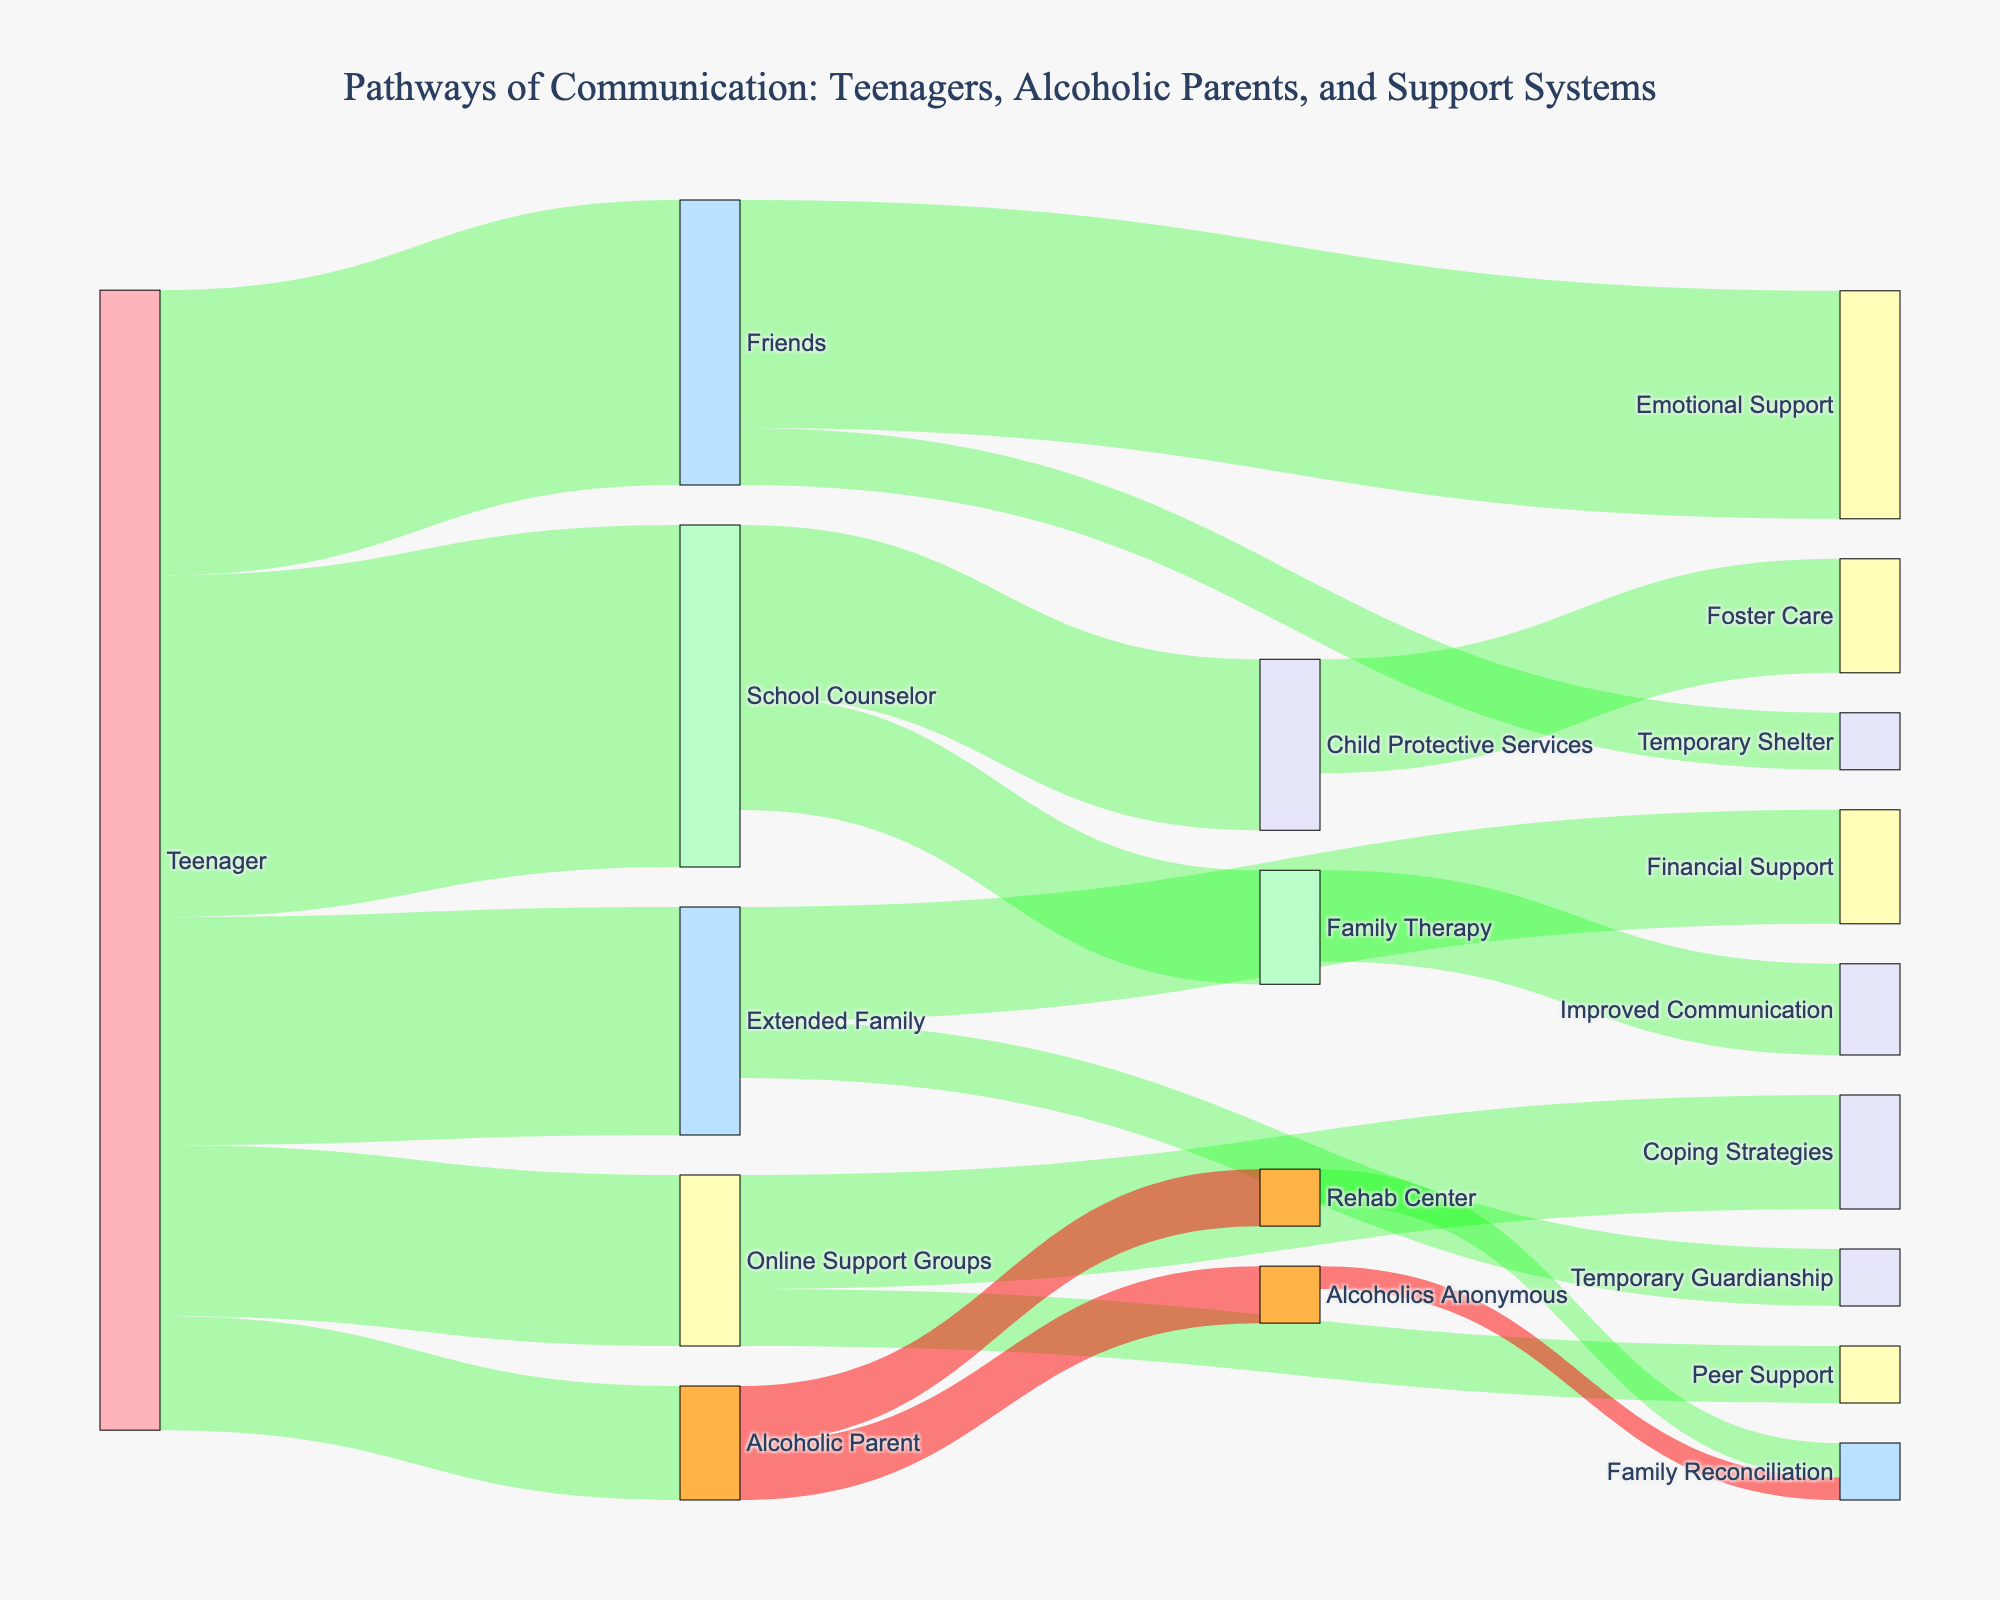what is the title of the Sankey diagram? The title is located at the top center of the diagram, providing a clear overall description of the visualization. It helps in understanding what the data is about immediately.
Answer: Pathways of Communication: Teenagers, Alcoholic Parents, and Support Systems which pathway has the largest value originating from the Teenager? To find the largest value originating from the Teenager, look at the thickness of the links extending from the Teenager and identify the one with the largest width. In this case, the largest value is visually evident by comparing the sizes of the different connections.
Answer: School Counselor how many different support sources are there for the teenager? To find this, count the individual nodes that have lines originating from the Teenager node. Each node connected directly to the Teenager represents a different support source.
Answer: 5 how many nodes are involved in total communication pathways? Count all the unique nodes (both sources and targets) in the diagram, as each node represents a different entity or process in the communication pathways.
Answer: 15 which pathway originating from the School Counselor has the least value? Look at the nodes connected to the School Counselor and compare the widths of the links to determine which one is the thinnest. The smallest value indicates the least pathway value.
Answer: Family Therapy compare the values of pathways from Friends. Which one offers more support, emotional or temporary shelter? Look at the two pathways originating from the Friends node and compare their widths. The pathway with the thicker width represents the higher value, hence more support. Emotional Support has a value of 20, and Temporary Shelter has a value of 5.
Answer: Emotional Support which node has pathways that lead directly to Family Reconciliation? Identify the nodes that connect directly to Family Reconciliation by following the links backwards from the Family Reconciliation node. There are two connections, so mention both.
Answer: Rehab Center, Alcoholics Anonymous what is the total value of all pathways originating from the Teenager? Sum the values of all pathways that start at the Teenager node, looking at each link separately and adding them up: 30 (School Counselor) + 25 (Friends) + 20 (Extended Family) + 15 (Online Support Groups) + 10 (Alcoholic Parent) = 100.
Answer: 100 which support system provides the most coping strategies, and what is the value? Identify the node linked to Coping Strategies and note the value of the link. Ensure there is only one link originating to accurately provide the source and the value.
Answer: Online Support Groups, 10 